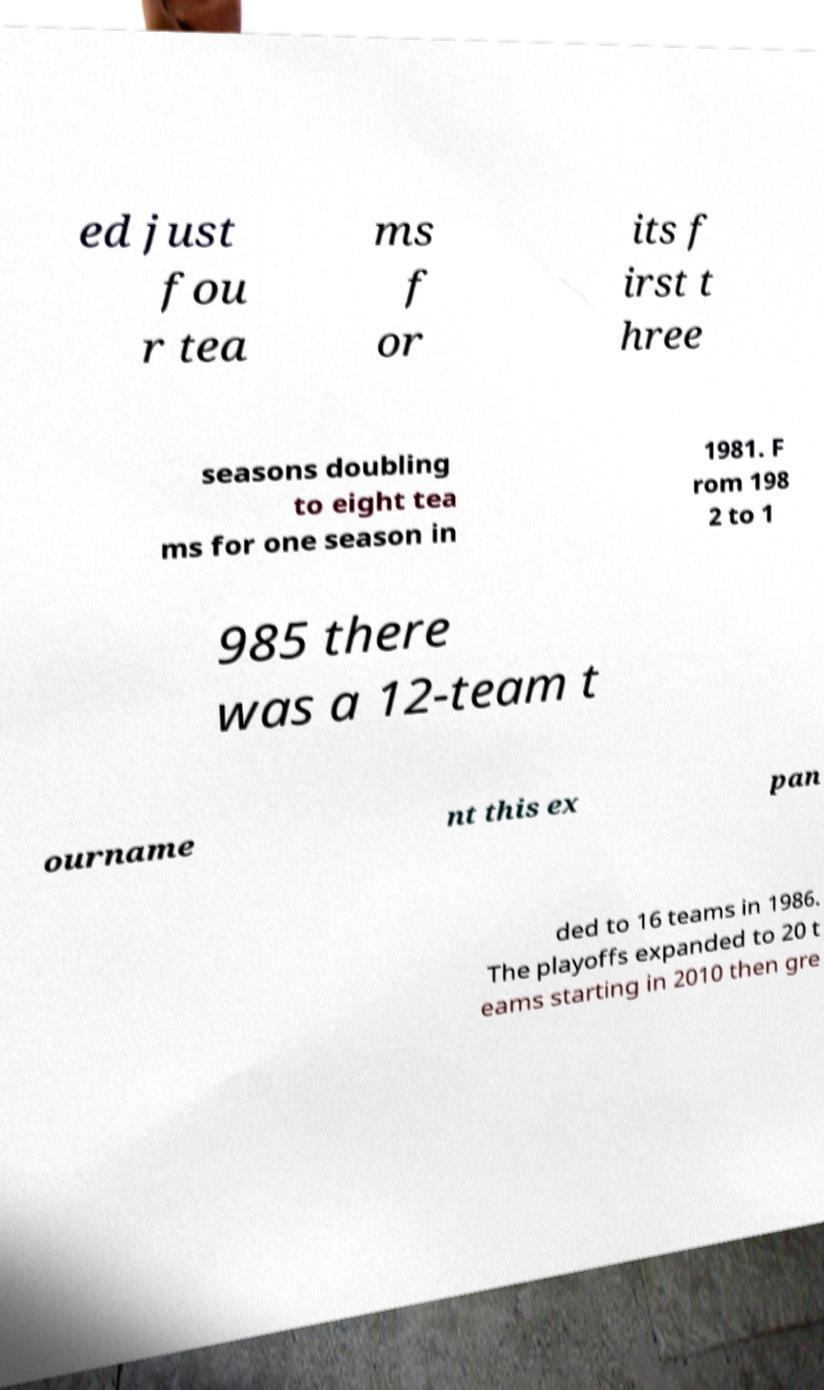I need the written content from this picture converted into text. Can you do that? ed just fou r tea ms f or its f irst t hree seasons doubling to eight tea ms for one season in 1981. F rom 198 2 to 1 985 there was a 12-team t ourname nt this ex pan ded to 16 teams in 1986. The playoffs expanded to 20 t eams starting in 2010 then gre 